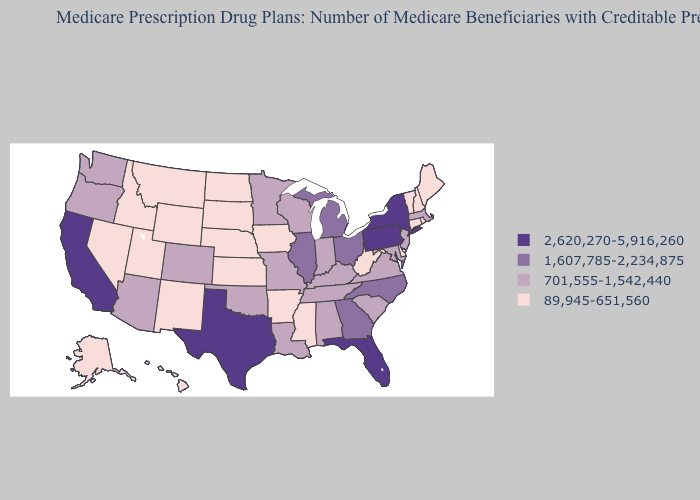What is the highest value in the Northeast ?
Concise answer only. 2,620,270-5,916,260. Which states hav the highest value in the West?
Be succinct. California. Which states have the lowest value in the Northeast?
Concise answer only. Connecticut, Maine, New Hampshire, Rhode Island, Vermont. What is the lowest value in states that border Vermont?
Write a very short answer. 89,945-651,560. What is the highest value in the MidWest ?
Keep it brief. 1,607,785-2,234,875. What is the value of New Mexico?
Short answer required. 89,945-651,560. What is the lowest value in states that border Arizona?
Give a very brief answer. 89,945-651,560. What is the value of Florida?
Short answer required. 2,620,270-5,916,260. What is the value of Texas?
Give a very brief answer. 2,620,270-5,916,260. What is the value of Texas?
Write a very short answer. 2,620,270-5,916,260. What is the lowest value in the USA?
Quick response, please. 89,945-651,560. Which states hav the highest value in the South?
Give a very brief answer. Florida, Texas. What is the value of Colorado?
Write a very short answer. 701,555-1,542,440. What is the value of Arkansas?
Be succinct. 89,945-651,560. Does Texas have the lowest value in the South?
Write a very short answer. No. 